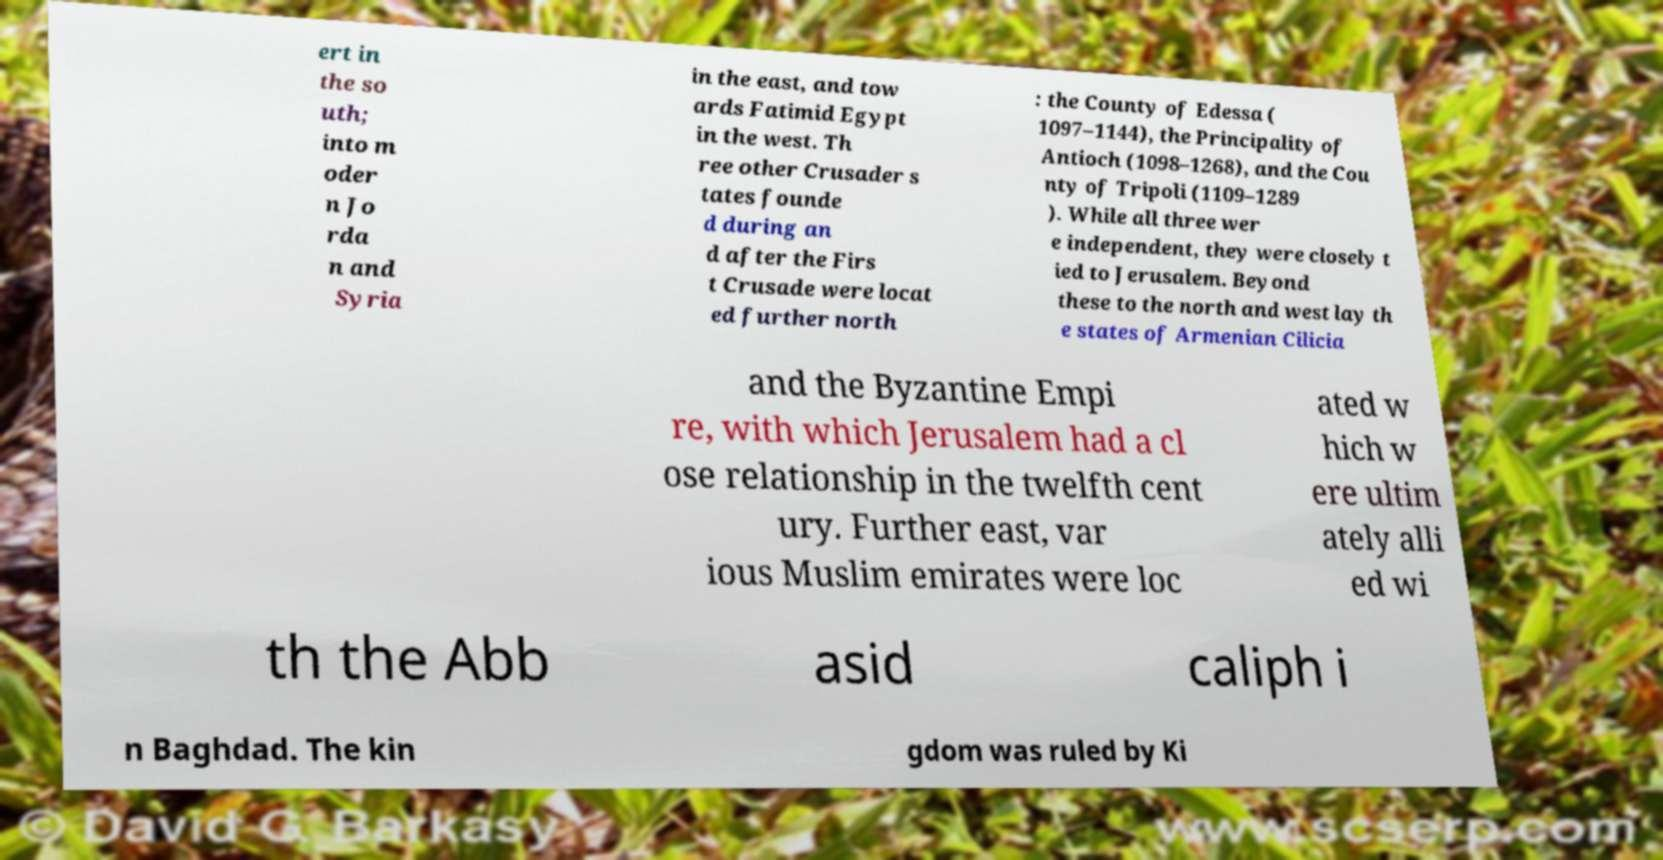Can you read and provide the text displayed in the image?This photo seems to have some interesting text. Can you extract and type it out for me? ert in the so uth; into m oder n Jo rda n and Syria in the east, and tow ards Fatimid Egypt in the west. Th ree other Crusader s tates founde d during an d after the Firs t Crusade were locat ed further north : the County of Edessa ( 1097–1144), the Principality of Antioch (1098–1268), and the Cou nty of Tripoli (1109–1289 ). While all three wer e independent, they were closely t ied to Jerusalem. Beyond these to the north and west lay th e states of Armenian Cilicia and the Byzantine Empi re, with which Jerusalem had a cl ose relationship in the twelfth cent ury. Further east, var ious Muslim emirates were loc ated w hich w ere ultim ately alli ed wi th the Abb asid caliph i n Baghdad. The kin gdom was ruled by Ki 